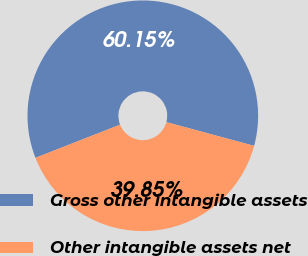<chart> <loc_0><loc_0><loc_500><loc_500><pie_chart><fcel>Gross other intangible assets<fcel>Other intangible assets net<nl><fcel>60.15%<fcel>39.85%<nl></chart> 